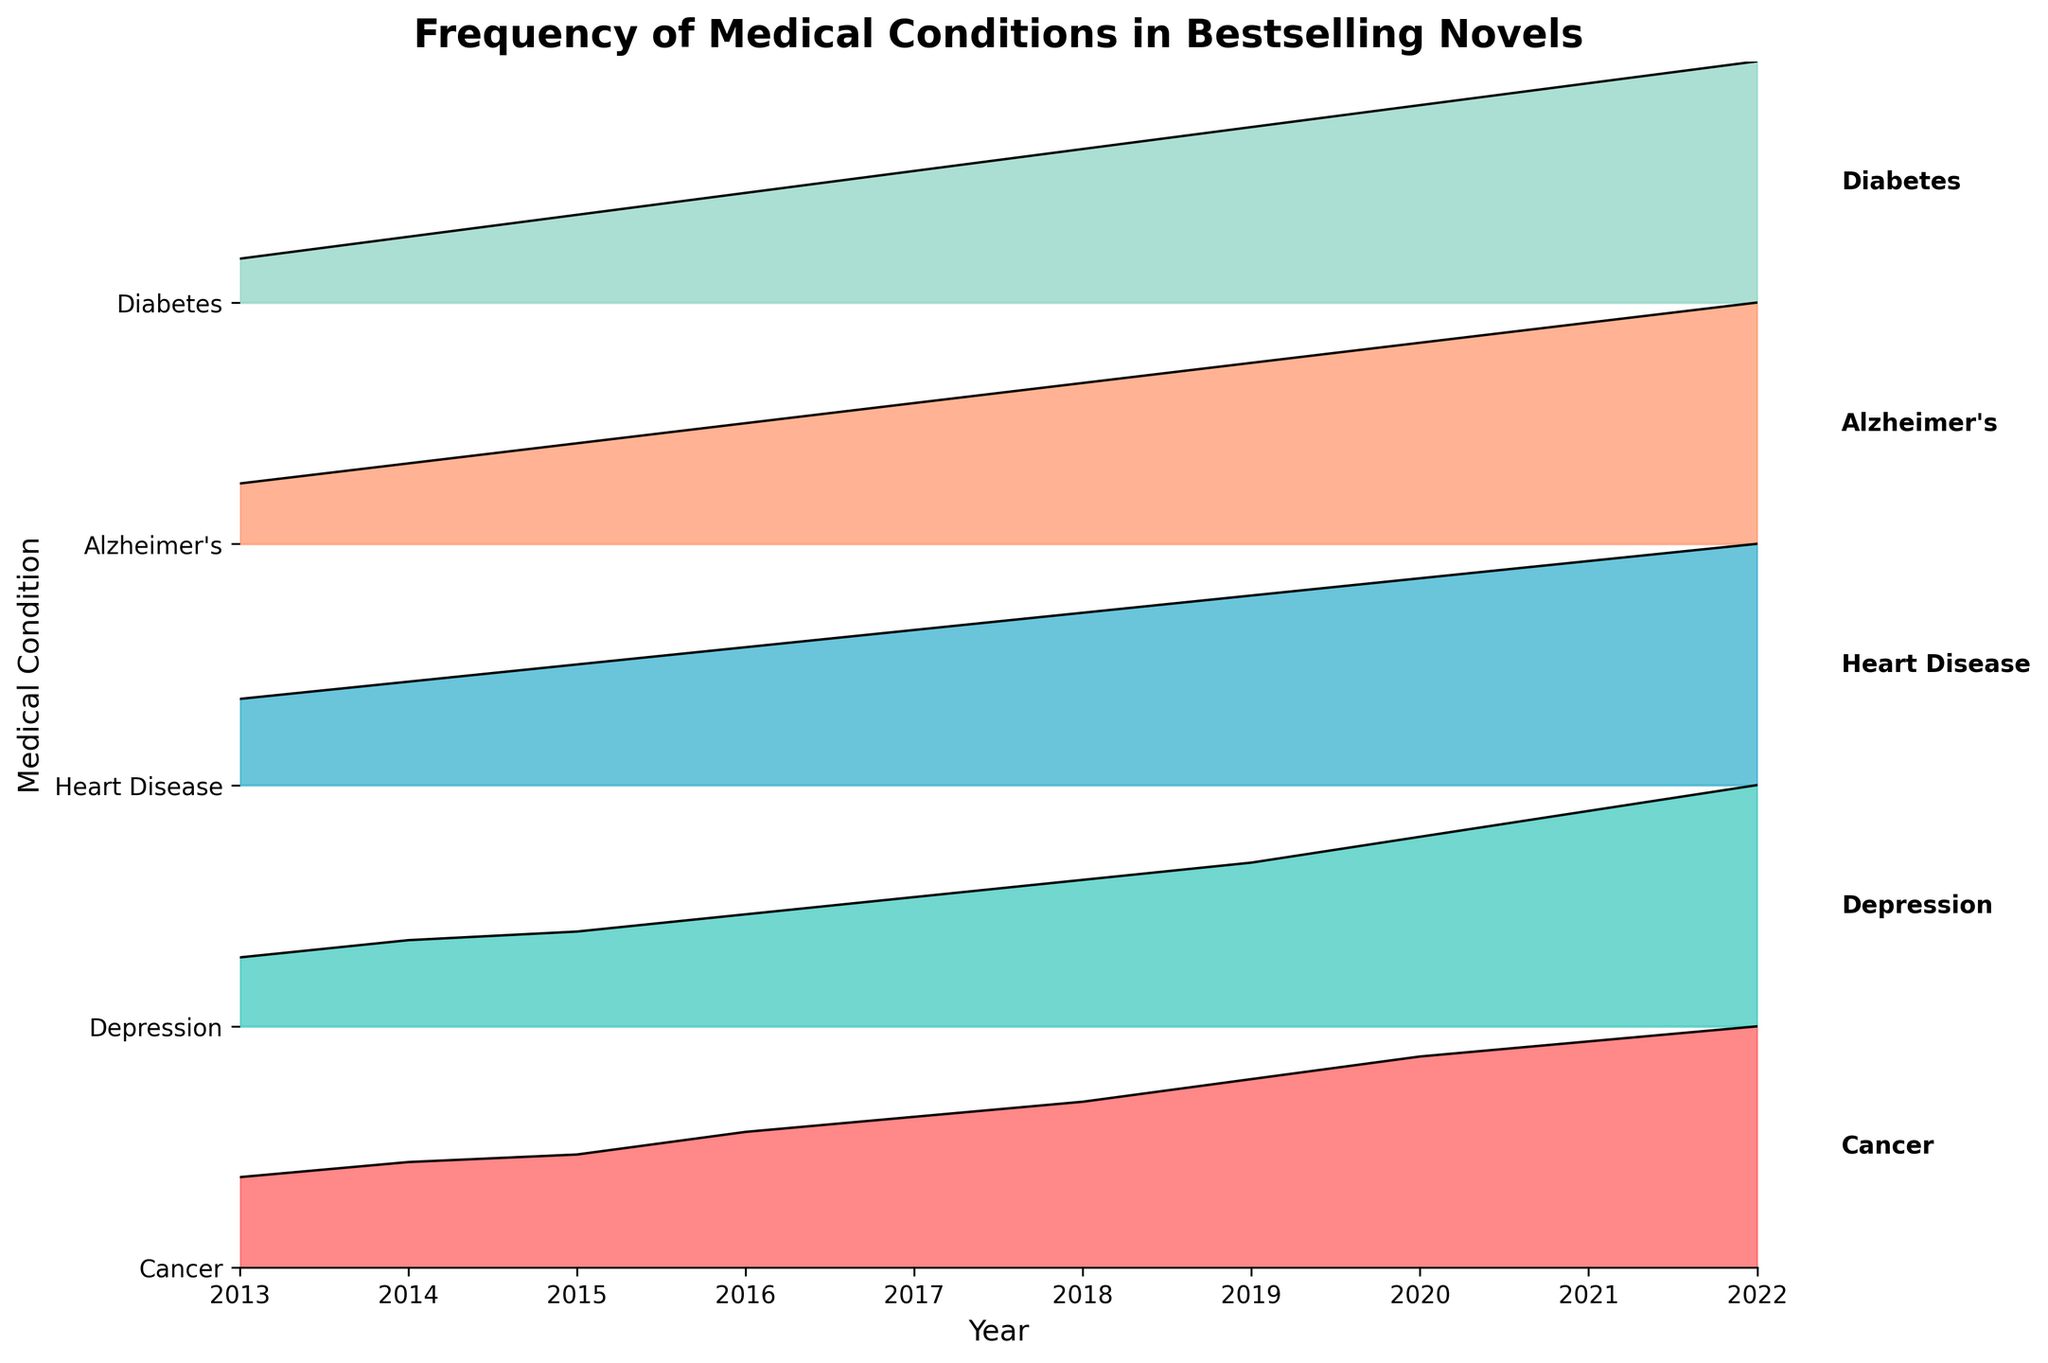What is the title of the Ridgeline plot? The title of the plot is displayed at the top of the figure. By carefully examining the top, we can see the title.
Answer: Frequency of Medical Conditions in Bestselling Novels How many different medical conditions are represented in this plot? The different medical conditions are represented by separate lines in the plot and listed on the y-axis. By counting these, we find the number of conditions.
Answer: 5 Which medical condition had the highest frequency in 2022? The plot shows the frequency of each medical condition as a filled area. By looking at 2022 on the x-axis and checking which condition has the highest point, we can identify the condition with the highest frequency.
Answer: Cancer In what year did "Depression" surpass 20 mentions? By focusing on the "Depression" line and finding the year on the x-axis where the frequency crosses the 20 mentions threshold, we can determine this year.
Answer: 2020 What is the trend in the frequency of "Alzheimer's" between 2013 and 2022? The "Alzheimer's" section of the plot shows the changes over the years. By observing the line for "Alzheimer's" from 2013 to 2022, we recognize the overall direction.
Answer: Increasing Calculate the average frequency of "Diabetes" mentions over the decade. Summing the frequencies for "Diabetes" from each year and dividing by the number of years (10) will give us the average. The yearly frequencies are 2, 3, 4, 5, 6, 7, 8, 9, 10, and 11. Adding these up, we get 65. Dividing by 10, we find the average.
Answer: 6.5 Compare the trends for "Cancer" and "Heart Disease." How do they differ? Observing the plot lines for "Cancer" and "Heart Disease," we need to note the overall directions and slopes to compare. "Cancer" shows a steep and consistent increase, while "Heart Disease" has a slower and more moderate increase.
Answer: Cancer increases faster During which years did "Depression" have a consistently increasing trend? By observing the "Depression" line on the plot and identifying the steady upward trajectory, we find that every year from 2013 to 2022 shows a consistent increase.
Answer: 2013 to 2022 What is the difference in the frequency of "Cancer" between 2013 and 2022? By noting the values for "Cancer" in 2013 and 2022 on the plot, we calculate the difference. In 2013, the frequency is 12. In 2022, it is 32. Subtracting these, we get the difference.
Answer: 20 Which condition had the lowest mention in 2013 and what was its frequency? By looking at the plot for 2013 and identifying the condition with the smallest area, we find this to be "Diabetes." The frequency is marked within the plot.
Answer: Diabetes, 2 